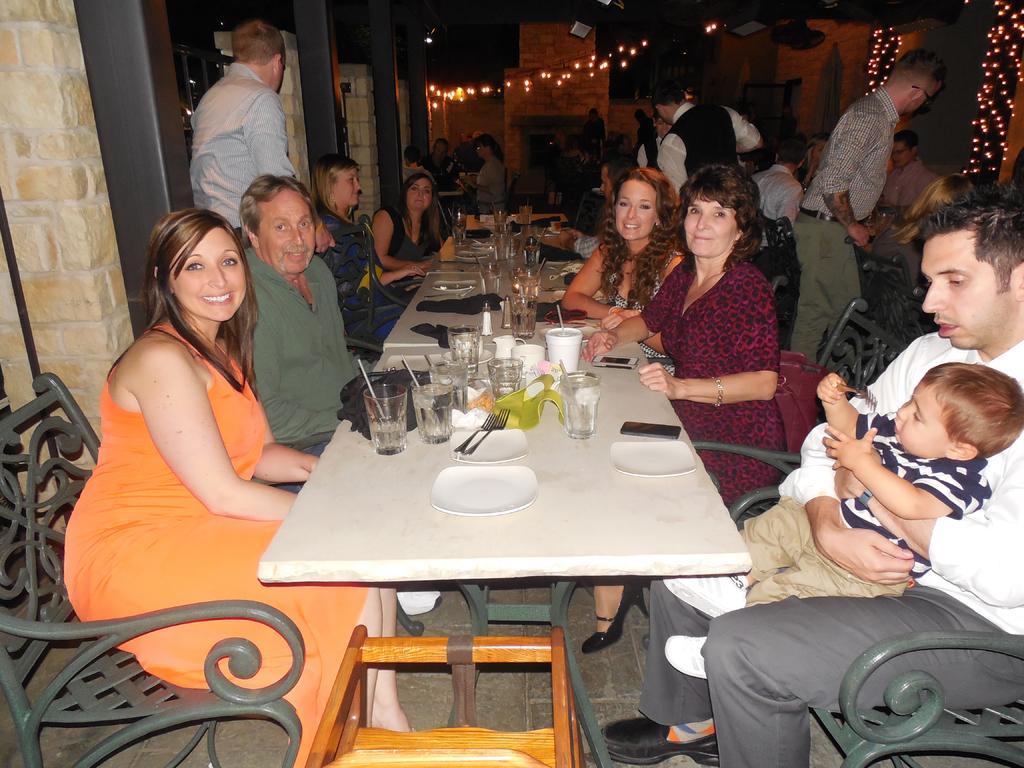How would you summarize this image in a sentence or two? In this picture there is a big dining table in the middle of the image and there are two rows of peoples those who are sitting on the chairs and facing to the front side of the image, there are different types of glasses, plates, and spoons on the table, it seems to be a hotel as the waiters are there at the right side of the image, the person who is sitting at the right side of the image he is holding a baby in his laps, there are different types of lights in the image. 